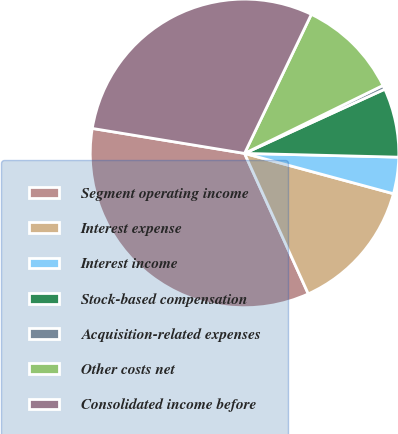Convert chart. <chart><loc_0><loc_0><loc_500><loc_500><pie_chart><fcel>Segment operating income<fcel>Interest expense<fcel>Interest income<fcel>Stock-based compensation<fcel>Acquisition-related expenses<fcel>Other costs net<fcel>Consolidated income before<nl><fcel>34.37%<fcel>14.01%<fcel>3.82%<fcel>7.22%<fcel>0.43%<fcel>10.61%<fcel>29.54%<nl></chart> 